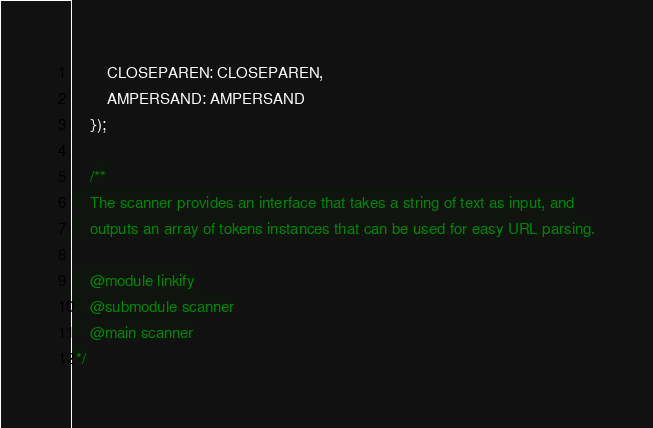Convert code to text. <code><loc_0><loc_0><loc_500><loc_500><_JavaScript_>		CLOSEPAREN: CLOSEPAREN,
		AMPERSAND: AMPERSAND
	});

	/**
 	The scanner provides an interface that takes a string of text as input, and
 	outputs an array of tokens instances that can be used for easy URL parsing.
 
 	@module linkify
 	@submodule scanner
 	@main scanner
 */
</code> 